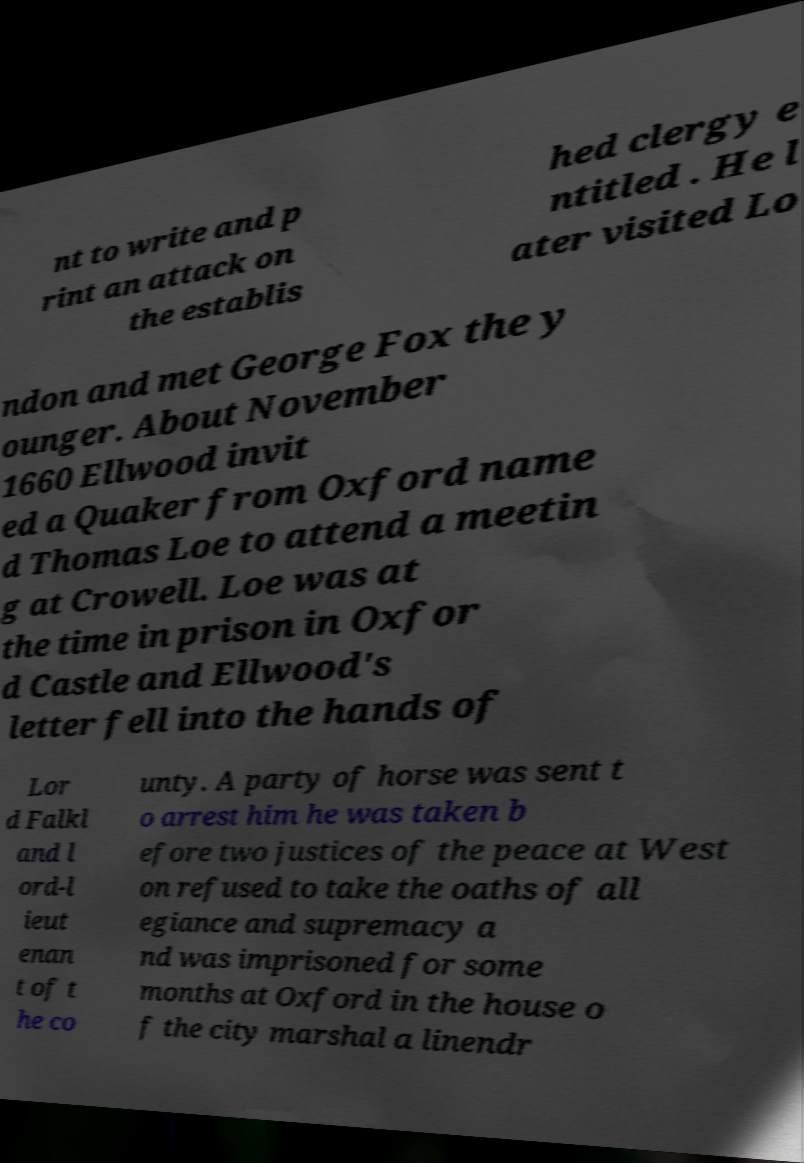Can you accurately transcribe the text from the provided image for me? nt to write and p rint an attack on the establis hed clergy e ntitled . He l ater visited Lo ndon and met George Fox the y ounger. About November 1660 Ellwood invit ed a Quaker from Oxford name d Thomas Loe to attend a meetin g at Crowell. Loe was at the time in prison in Oxfor d Castle and Ellwood's letter fell into the hands of Lor d Falkl and l ord-l ieut enan t of t he co unty. A party of horse was sent t o arrest him he was taken b efore two justices of the peace at West on refused to take the oaths of all egiance and supremacy a nd was imprisoned for some months at Oxford in the house o f the city marshal a linendr 